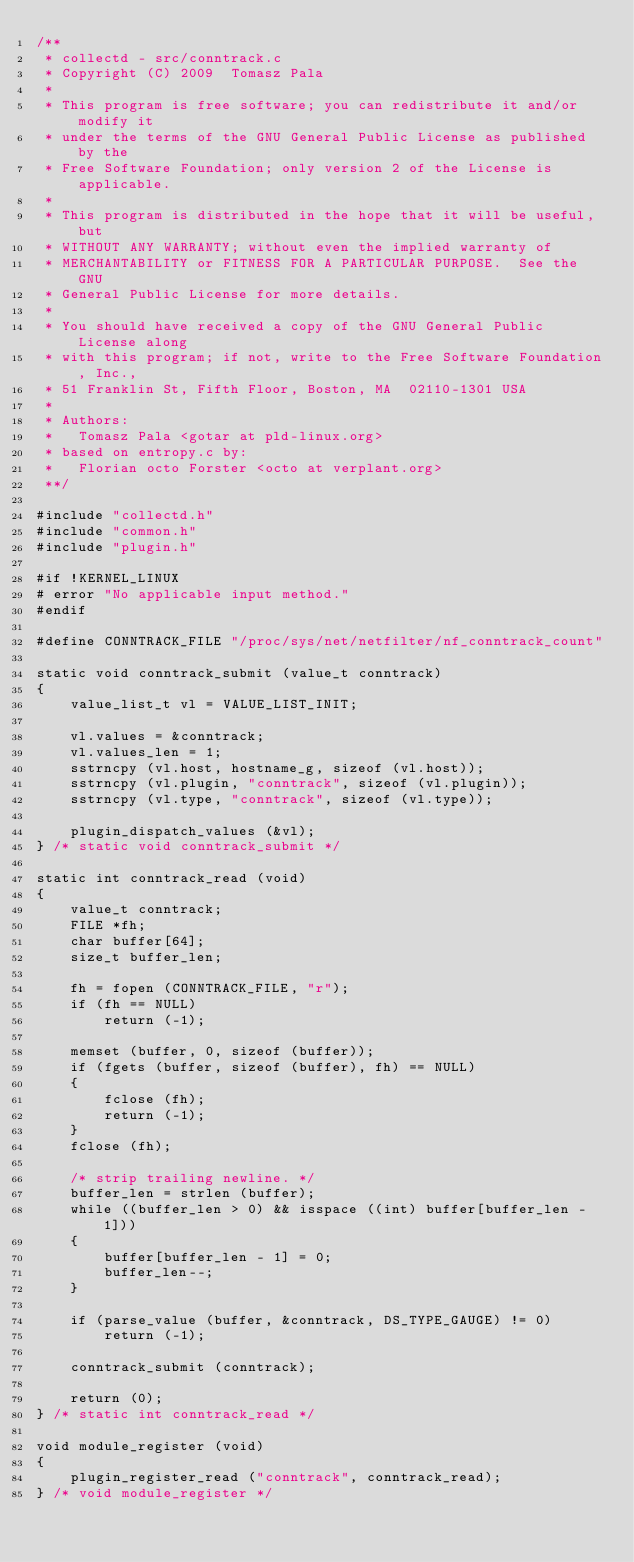Convert code to text. <code><loc_0><loc_0><loc_500><loc_500><_C_>/**
 * collectd - src/conntrack.c
 * Copyright (C) 2009  Tomasz Pala
 *
 * This program is free software; you can redistribute it and/or modify it
 * under the terms of the GNU General Public License as published by the
 * Free Software Foundation; only version 2 of the License is applicable.
 *
 * This program is distributed in the hope that it will be useful, but
 * WITHOUT ANY WARRANTY; without even the implied warranty of
 * MERCHANTABILITY or FITNESS FOR A PARTICULAR PURPOSE.  See the GNU
 * General Public License for more details.
 *
 * You should have received a copy of the GNU General Public License along
 * with this program; if not, write to the Free Software Foundation, Inc.,
 * 51 Franklin St, Fifth Floor, Boston, MA  02110-1301 USA
 *
 * Authors:
 *   Tomasz Pala <gotar at pld-linux.org>
 * based on entropy.c by:
 *   Florian octo Forster <octo at verplant.org>
 **/

#include "collectd.h"
#include "common.h"
#include "plugin.h"

#if !KERNEL_LINUX
# error "No applicable input method."
#endif

#define CONNTRACK_FILE "/proc/sys/net/netfilter/nf_conntrack_count"

static void conntrack_submit (value_t conntrack)
{
	value_list_t vl = VALUE_LIST_INIT;

	vl.values = &conntrack;
	vl.values_len = 1;
	sstrncpy (vl.host, hostname_g, sizeof (vl.host));
	sstrncpy (vl.plugin, "conntrack", sizeof (vl.plugin));
	sstrncpy (vl.type, "conntrack", sizeof (vl.type));

	plugin_dispatch_values (&vl);
} /* static void conntrack_submit */

static int conntrack_read (void)
{
	value_t conntrack;
	FILE *fh;
	char buffer[64];
	size_t buffer_len;

	fh = fopen (CONNTRACK_FILE, "r");
	if (fh == NULL)
		return (-1);

	memset (buffer, 0, sizeof (buffer));
	if (fgets (buffer, sizeof (buffer), fh) == NULL)
	{
		fclose (fh);
		return (-1);
	}
	fclose (fh);

	/* strip trailing newline. */
	buffer_len = strlen (buffer);
	while ((buffer_len > 0) && isspace ((int) buffer[buffer_len - 1]))
	{
		buffer[buffer_len - 1] = 0;
		buffer_len--;
	}

	if (parse_value (buffer, &conntrack, DS_TYPE_GAUGE) != 0)
		return (-1);

	conntrack_submit (conntrack);

	return (0);
} /* static int conntrack_read */

void module_register (void)
{
	plugin_register_read ("conntrack", conntrack_read);
} /* void module_register */
</code> 